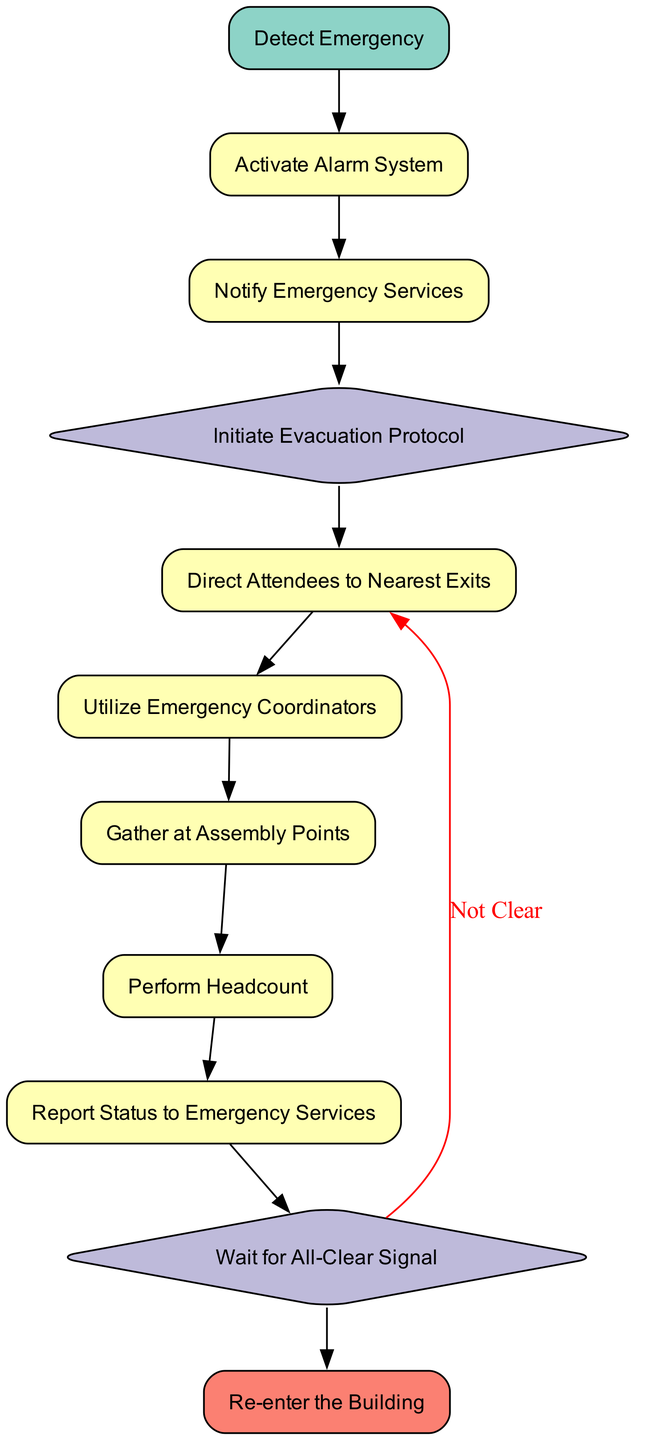What is the first step in the emergency evacuation procedure? The first step in the procedure is to "Detect Emergency," which identifies the alert regarding an emergency situation.
Answer: Detect Emergency How many processes are involved in the diagram? By counting the nodes categorized as 'process', we identify that there are six processes: Activate Alarm System, Notify Emergency Services, Direct Attendees to Nearest Exits, Utilize Emergency Coordinators, Gather at Assembly Points, and Perform Headcount.
Answer: Six What happens if the all-clear signal is not received? If the all-clear signal is not received, the flow indicates that attendees will remain at assembly points, as represented by a decision node labeled "Wait for All-Clear Signal," which connects back to an earlier process.
Answer: Remain at assembly points What is the role of emergency coordinators during an evacuation? The role of emergency coordinators is to assist with guiding attendees to exits and ensuring calm, as defined in the process node labeled "Utilize Emergency Coordinators."
Answer: Guide attendees After performing a headcount, what information is reported to emergency services? The information reported to emergency services after performing a headcount includes the status of the headcount and any known missing persons, as noted in the process node "Report Status to Emergency Services."
Answer: Headcount and missing persons How many decision points are in the evacuation procedure? There are two decision points in the evacuation procedure: "Initiate Evacuation Protocol" and "Wait for All-Clear Signal." These nodes direct the flow based on the situation and the need to evacuate or await further instructions.
Answer: Two What is the exit point of the flow chart? The exit point of the flow chart is the node labeled "Re-enter the Building," which signifies the end of the procedure once the building is declared safe.
Answer: Re-enter the Building What must attendees do after being directed to assembly points? After being directed to assembly points, attendees must wait for further instructions, primarily to perform a headcount and ensure everyone's safety before re-entering the facility.
Answer: Perform headcount What process follows the notification of emergency services? Following the notification of emergency services, the next step is to "Initiate Evacuation Protocol," which determines if evacuation is necessary based on the type of emergency indicated.
Answer: Initiate Evacuation Protocol 